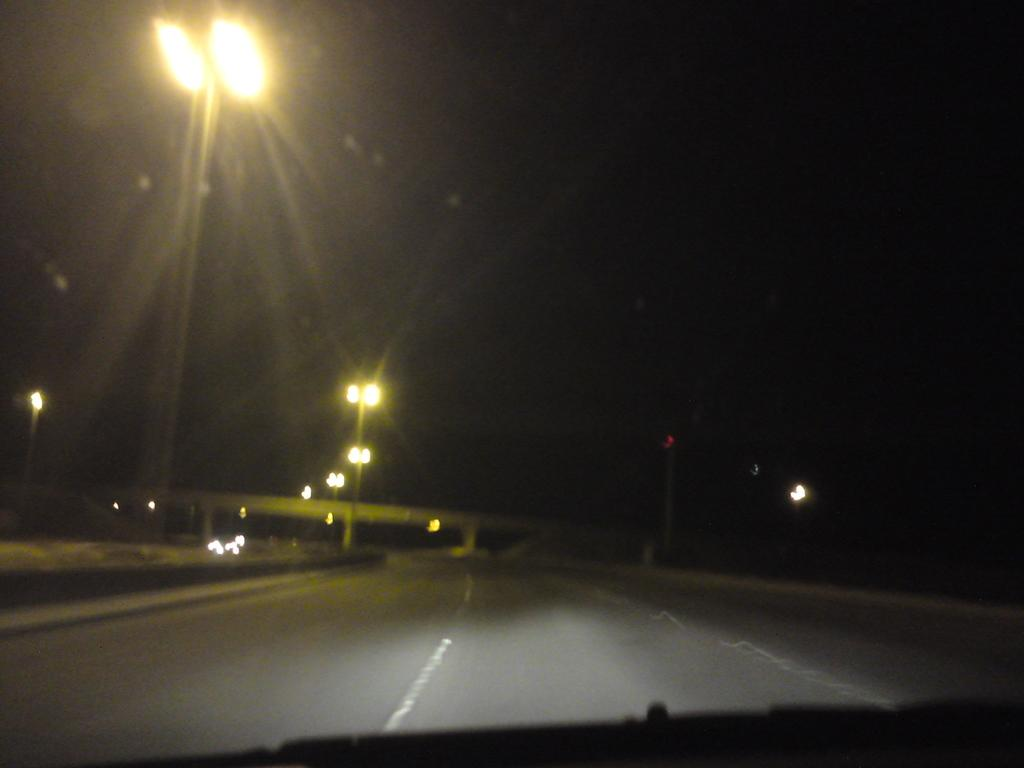What type of infrastructure is visible in the image? There is a road, a pole, and a bridge visible in the image. What is attached to the pole in the image? There are lights attached to the pole in the image. What type of structure is the bridge in the image? The bridge in the image is a crossing for the road. What type of poison can be seen dripping from the bridge in the image? There is no poison present in the image; it features a road, pole, lights, and a bridge. What is the sun's position in the image? The facts provided do not mention the sun or its position in the image. 